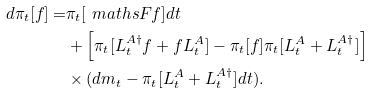Convert formula to latex. <formula><loc_0><loc_0><loc_500><loc_500>d \pi _ { t } [ f ] = & \pi _ { t } [ \ m a t h s { F } f ] d t \\ & + \left [ \pi _ { t } [ L _ { t } ^ { A \dag } f + f L _ { t } ^ { A } ] - \pi _ { t } [ f ] \pi _ { t } [ L _ { t } ^ { A } + L _ { t } ^ { A \dag } ] \right ] \\ & \times ( d m _ { t } - \pi _ { t } [ L _ { t } ^ { A } + L _ { t } ^ { A \dag } ] d t ) .</formula> 